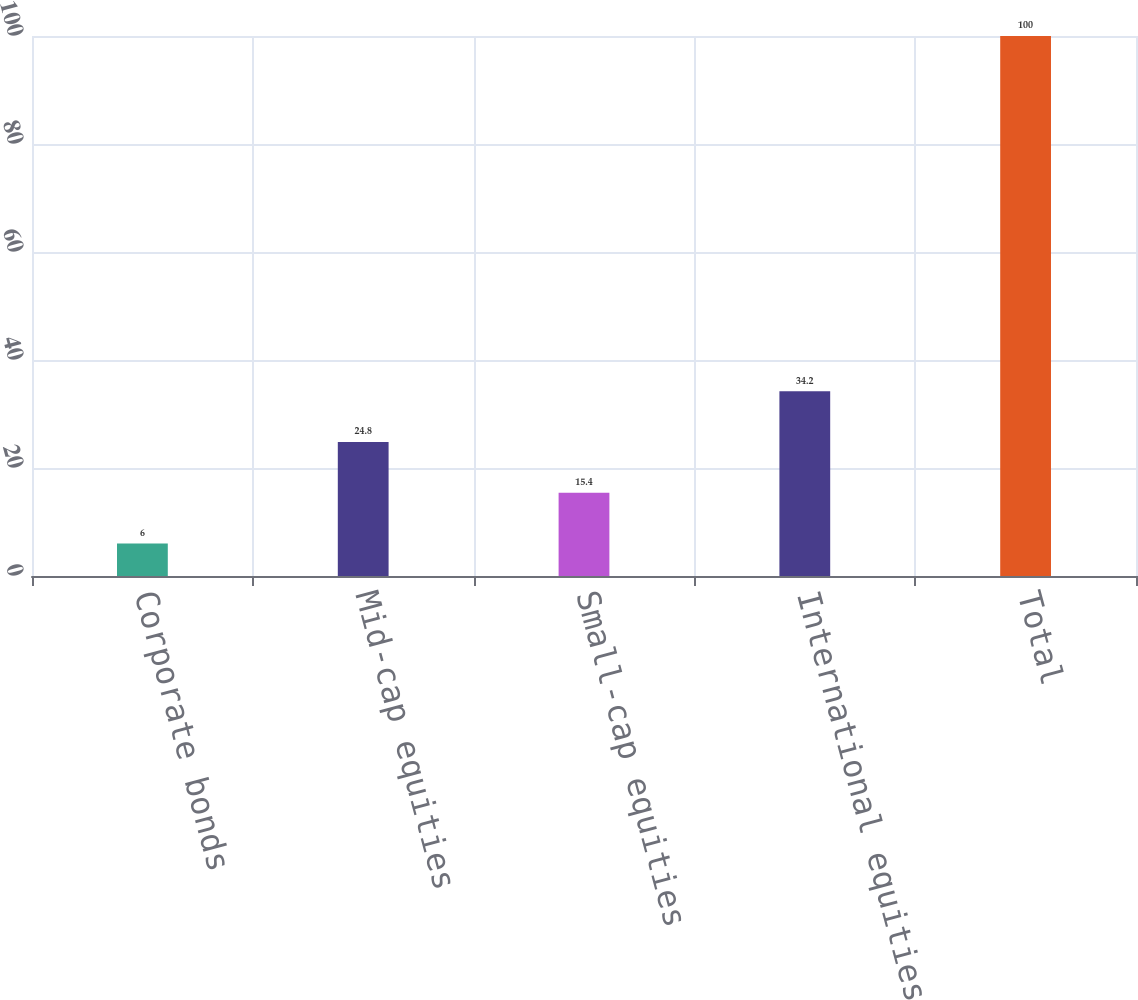Convert chart. <chart><loc_0><loc_0><loc_500><loc_500><bar_chart><fcel>Corporate bonds<fcel>Mid-cap equities<fcel>Small-cap equities<fcel>International equities<fcel>Total<nl><fcel>6<fcel>24.8<fcel>15.4<fcel>34.2<fcel>100<nl></chart> 